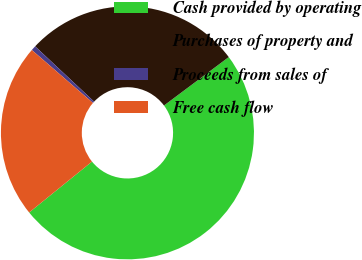Convert chart. <chart><loc_0><loc_0><loc_500><loc_500><pie_chart><fcel>Cash provided by operating<fcel>Purchases of property and<fcel>Proceeds from sales of<fcel>Free cash flow<nl><fcel>49.38%<fcel>27.8%<fcel>0.62%<fcel>22.2%<nl></chart> 